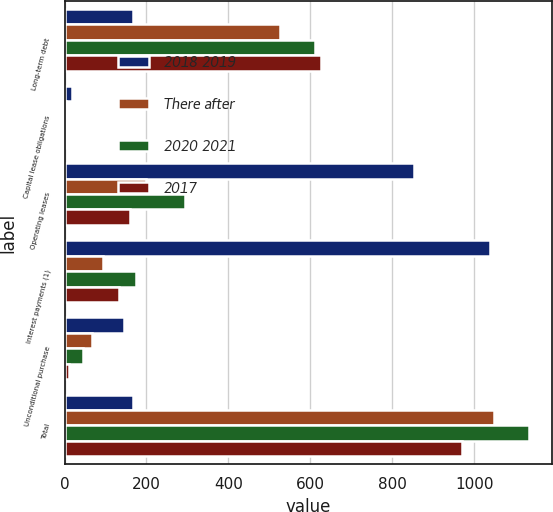Convert chart to OTSL. <chart><loc_0><loc_0><loc_500><loc_500><stacked_bar_chart><ecel><fcel>Long-term debt<fcel>Capital lease obligations<fcel>Operating leases<fcel>Interest payments (1)<fcel>Unconditional purchase<fcel>Total<nl><fcel>2018 2019<fcel>167<fcel>18<fcel>854<fcel>1038<fcel>144<fcel>167<nl><fcel>There after<fcel>526<fcel>4<fcel>200<fcel>95<fcel>66<fcel>1049<nl><fcel>2020 2021<fcel>612<fcel>6<fcel>295<fcel>175<fcel>45<fcel>1133<nl><fcel>2017<fcel>627<fcel>3<fcel>159<fcel>133<fcel>11<fcel>971<nl></chart> 